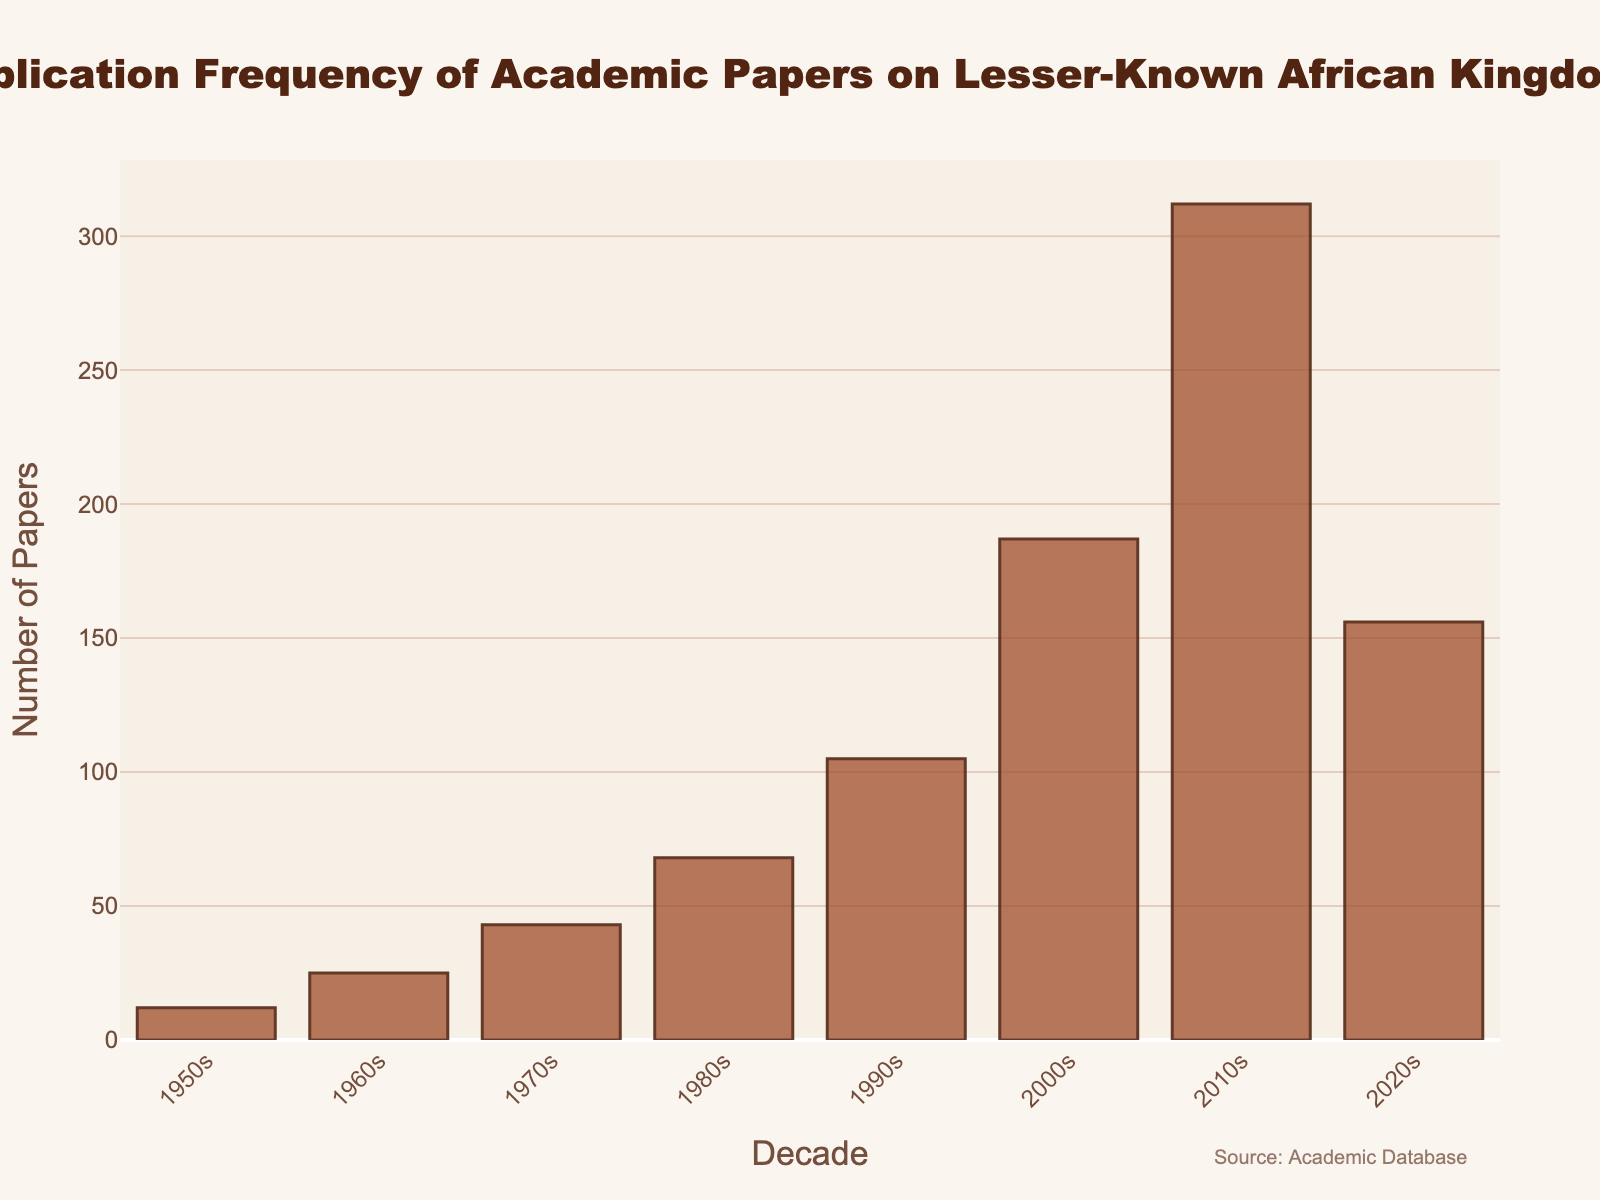What is the overall trend in the publication frequency of academic papers on lesser-known African kingdoms from the 1950s to the 2020s? Observing the bars from left to right over the decades, the publication frequency generally shows an upward trend until the 2010s, followed by a decline in the 2020s.
Answer: Increasing until 2010s, then decreasing Which decade saw the highest number of academic papers published on lesser-known African kingdoms? By comparing the heights of all the bars, the bar for the 2010s is the tallest, indicating it had the highest number of publications.
Answer: 2010s How does the number of papers published in the 2000s compare to those published in the 2020s? Looking at the height of bars for these two decades, the bar for the 2000s is taller than the bar for the 2020s. Therefore, more papers were published in the 2000s than in the 2020s.
Answer: 2000s had more What is the total number of academic papers published on lesser-known African kingdoms from the 1950s to the 2010s? Add the number of papers for each decade from the 1950s to the 2010s: 12 + 25 + 43 + 68 + 105 + 187 + 312 = 752.
Answer: 752 How many more papers were published in the 2010s compared to the 1950s? Subtract the number of papers published in the 1950s from the number published in the 2010s: 312 - 12 = 300.
Answer: 300 Between which consecutive decades was the greatest increase in the number of publications observed? Calculate the difference in the number of papers between each consecutive decade and compare: 1960s-1950s (25-12=13), 1970s-1960s (43-25=18), 1980s-1970s (68-43=25), 1990s-1980s (105-68=37), 2000s-1990s (187-105=82), 2010s-2000s (312-187=125), 2020s-2010s (156-312=-156). The greatest increase is between 2000s and 2010s.
Answer: 2000s to 2010s Which decade had nearly twice the number of publications as the 1990s? Compare the number of papers published in each decade to twice the number published in the 1990s, which is 105*2=210. The decade closest to 210 is the 2000s with 187 papers.
Answer: 2000s What is the average number of papers published per decade from the 1950s to the 2020s? Total number of papers from the 1950s to the 2020s is 948. Divide this by the number of decades (8): 948 / 8 = 118.5.
Answer: 118.5 How did the number of academic papers change from the 1960s to the 1980s? Track the number of papers published in the 1960s, 1970s, and 1980s: the numbers increased successively from 25 to 43 to 68.
Answer: Increased Is there any decade where the number of published papers decreased compared to the previous decade? If so, which one? Observe the sequence of bars to see any decrease. The publication number drops from the 2010s (312) to the 2020s (156).
Answer: 2020s 